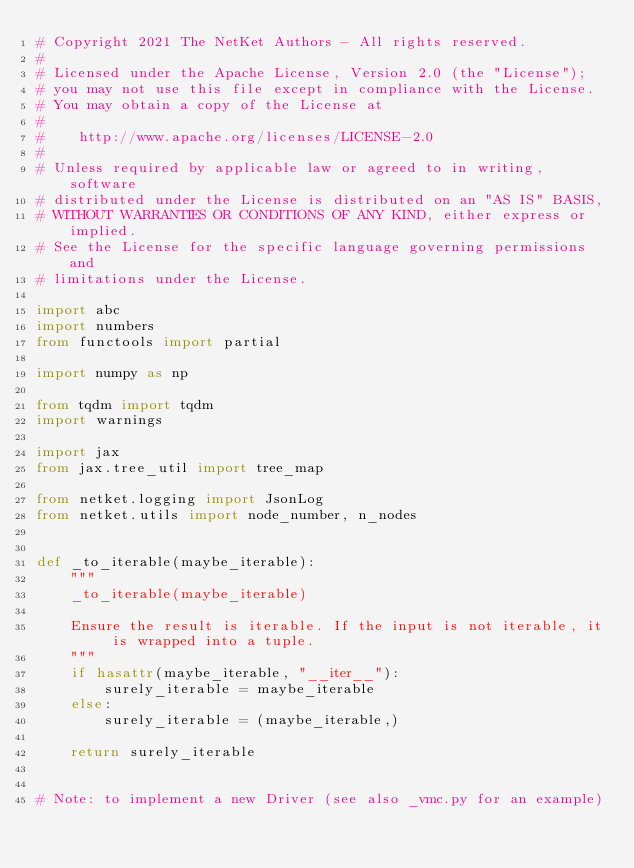Convert code to text. <code><loc_0><loc_0><loc_500><loc_500><_Python_># Copyright 2021 The NetKet Authors - All rights reserved.
#
# Licensed under the Apache License, Version 2.0 (the "License");
# you may not use this file except in compliance with the License.
# You may obtain a copy of the License at
#
#    http://www.apache.org/licenses/LICENSE-2.0
#
# Unless required by applicable law or agreed to in writing, software
# distributed under the License is distributed on an "AS IS" BASIS,
# WITHOUT WARRANTIES OR CONDITIONS OF ANY KIND, either express or implied.
# See the License for the specific language governing permissions and
# limitations under the License.

import abc
import numbers
from functools import partial

import numpy as np

from tqdm import tqdm
import warnings

import jax
from jax.tree_util import tree_map

from netket.logging import JsonLog
from netket.utils import node_number, n_nodes


def _to_iterable(maybe_iterable):
    """
    _to_iterable(maybe_iterable)

    Ensure the result is iterable. If the input is not iterable, it is wrapped into a tuple.
    """
    if hasattr(maybe_iterable, "__iter__"):
        surely_iterable = maybe_iterable
    else:
        surely_iterable = (maybe_iterable,)

    return surely_iterable


# Note: to implement a new Driver (see also _vmc.py for an example)</code> 